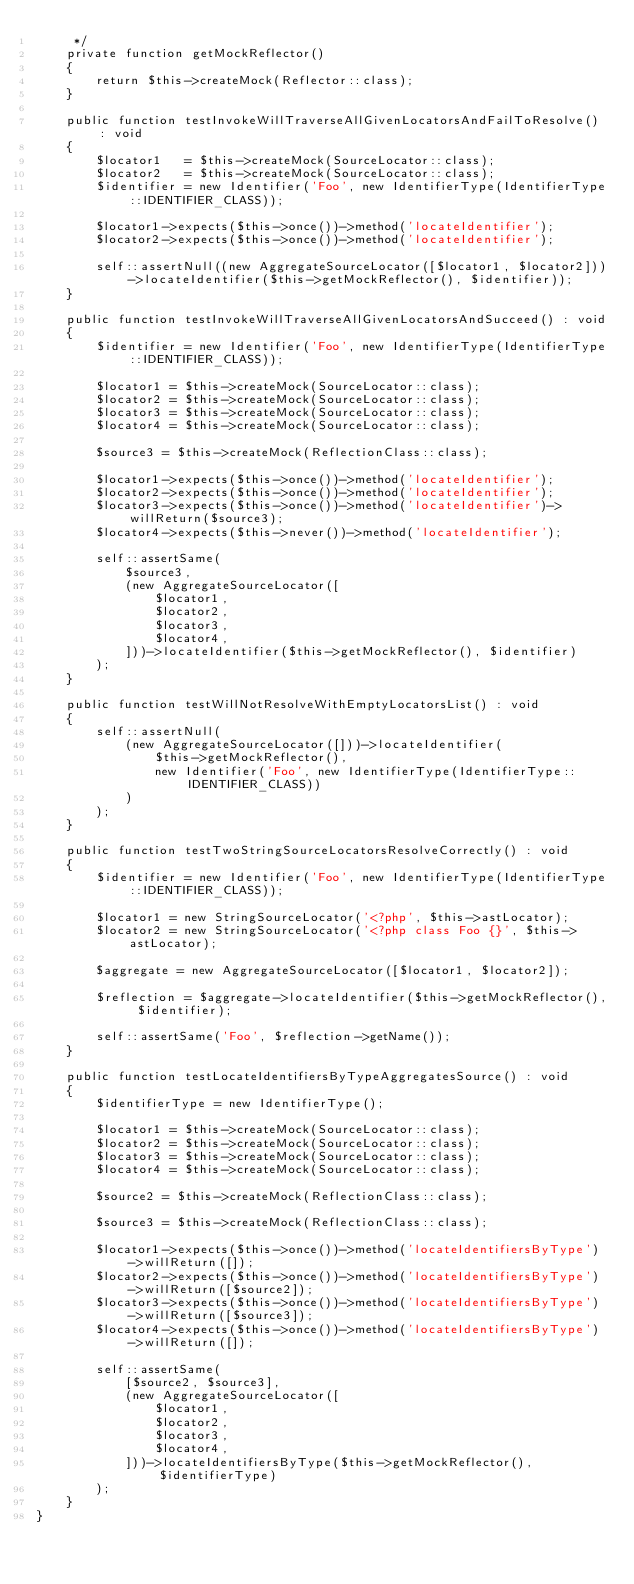Convert code to text. <code><loc_0><loc_0><loc_500><loc_500><_PHP_>     */
    private function getMockReflector()
    {
        return $this->createMock(Reflector::class);
    }

    public function testInvokeWillTraverseAllGivenLocatorsAndFailToResolve() : void
    {
        $locator1   = $this->createMock(SourceLocator::class);
        $locator2   = $this->createMock(SourceLocator::class);
        $identifier = new Identifier('Foo', new IdentifierType(IdentifierType::IDENTIFIER_CLASS));

        $locator1->expects($this->once())->method('locateIdentifier');
        $locator2->expects($this->once())->method('locateIdentifier');

        self::assertNull((new AggregateSourceLocator([$locator1, $locator2]))->locateIdentifier($this->getMockReflector(), $identifier));
    }

    public function testInvokeWillTraverseAllGivenLocatorsAndSucceed() : void
    {
        $identifier = new Identifier('Foo', new IdentifierType(IdentifierType::IDENTIFIER_CLASS));

        $locator1 = $this->createMock(SourceLocator::class);
        $locator2 = $this->createMock(SourceLocator::class);
        $locator3 = $this->createMock(SourceLocator::class);
        $locator4 = $this->createMock(SourceLocator::class);

        $source3 = $this->createMock(ReflectionClass::class);

        $locator1->expects($this->once())->method('locateIdentifier');
        $locator2->expects($this->once())->method('locateIdentifier');
        $locator3->expects($this->once())->method('locateIdentifier')->willReturn($source3);
        $locator4->expects($this->never())->method('locateIdentifier');

        self::assertSame(
            $source3,
            (new AggregateSourceLocator([
                $locator1,
                $locator2,
                $locator3,
                $locator4,
            ]))->locateIdentifier($this->getMockReflector(), $identifier)
        );
    }

    public function testWillNotResolveWithEmptyLocatorsList() : void
    {
        self::assertNull(
            (new AggregateSourceLocator([]))->locateIdentifier(
                $this->getMockReflector(),
                new Identifier('Foo', new IdentifierType(IdentifierType::IDENTIFIER_CLASS))
            )
        );
    }

    public function testTwoStringSourceLocatorsResolveCorrectly() : void
    {
        $identifier = new Identifier('Foo', new IdentifierType(IdentifierType::IDENTIFIER_CLASS));

        $locator1 = new StringSourceLocator('<?php', $this->astLocator);
        $locator2 = new StringSourceLocator('<?php class Foo {}', $this->astLocator);

        $aggregate = new AggregateSourceLocator([$locator1, $locator2]);

        $reflection = $aggregate->locateIdentifier($this->getMockReflector(), $identifier);

        self::assertSame('Foo', $reflection->getName());
    }

    public function testLocateIdentifiersByTypeAggregatesSource() : void
    {
        $identifierType = new IdentifierType();

        $locator1 = $this->createMock(SourceLocator::class);
        $locator2 = $this->createMock(SourceLocator::class);
        $locator3 = $this->createMock(SourceLocator::class);
        $locator4 = $this->createMock(SourceLocator::class);

        $source2 = $this->createMock(ReflectionClass::class);

        $source3 = $this->createMock(ReflectionClass::class);

        $locator1->expects($this->once())->method('locateIdentifiersByType')->willReturn([]);
        $locator2->expects($this->once())->method('locateIdentifiersByType')->willReturn([$source2]);
        $locator3->expects($this->once())->method('locateIdentifiersByType')->willReturn([$source3]);
        $locator4->expects($this->once())->method('locateIdentifiersByType')->willReturn([]);

        self::assertSame(
            [$source2, $source3],
            (new AggregateSourceLocator([
                $locator1,
                $locator2,
                $locator3,
                $locator4,
            ]))->locateIdentifiersByType($this->getMockReflector(), $identifierType)
        );
    }
}
</code> 